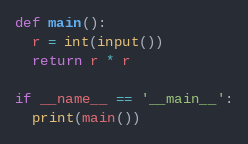Convert code to text. <code><loc_0><loc_0><loc_500><loc_500><_Python_>def main():
  r = int(input())
  return r * r

if __name__ == '__main__':
  print(main())</code> 